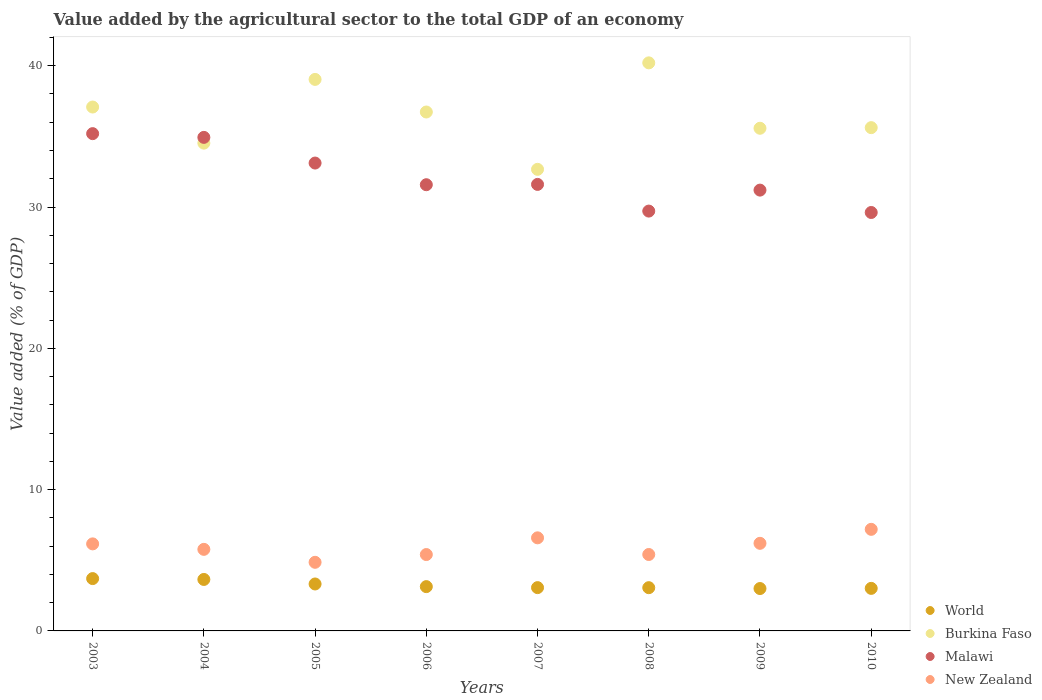How many different coloured dotlines are there?
Offer a terse response. 4. Is the number of dotlines equal to the number of legend labels?
Provide a short and direct response. Yes. What is the value added by the agricultural sector to the total GDP in Burkina Faso in 2009?
Your answer should be very brief. 35.57. Across all years, what is the maximum value added by the agricultural sector to the total GDP in Malawi?
Your response must be concise. 35.19. Across all years, what is the minimum value added by the agricultural sector to the total GDP in New Zealand?
Offer a terse response. 4.86. In which year was the value added by the agricultural sector to the total GDP in New Zealand maximum?
Your answer should be compact. 2010. In which year was the value added by the agricultural sector to the total GDP in Burkina Faso minimum?
Provide a succinct answer. 2007. What is the total value added by the agricultural sector to the total GDP in Burkina Faso in the graph?
Make the answer very short. 291.41. What is the difference between the value added by the agricultural sector to the total GDP in Burkina Faso in 2004 and that in 2007?
Provide a short and direct response. 1.85. What is the difference between the value added by the agricultural sector to the total GDP in Malawi in 2006 and the value added by the agricultural sector to the total GDP in Burkina Faso in 2009?
Give a very brief answer. -4. What is the average value added by the agricultural sector to the total GDP in Burkina Faso per year?
Give a very brief answer. 36.43. In the year 2005, what is the difference between the value added by the agricultural sector to the total GDP in New Zealand and value added by the agricultural sector to the total GDP in Burkina Faso?
Make the answer very short. -34.17. What is the ratio of the value added by the agricultural sector to the total GDP in Burkina Faso in 2005 to that in 2009?
Ensure brevity in your answer.  1.1. Is the value added by the agricultural sector to the total GDP in Malawi in 2009 less than that in 2010?
Offer a very short reply. No. Is the difference between the value added by the agricultural sector to the total GDP in New Zealand in 2009 and 2010 greater than the difference between the value added by the agricultural sector to the total GDP in Burkina Faso in 2009 and 2010?
Provide a short and direct response. No. What is the difference between the highest and the second highest value added by the agricultural sector to the total GDP in World?
Give a very brief answer. 0.06. What is the difference between the highest and the lowest value added by the agricultural sector to the total GDP in Malawi?
Ensure brevity in your answer.  5.58. In how many years, is the value added by the agricultural sector to the total GDP in Malawi greater than the average value added by the agricultural sector to the total GDP in Malawi taken over all years?
Your response must be concise. 3. Is the sum of the value added by the agricultural sector to the total GDP in New Zealand in 2003 and 2008 greater than the maximum value added by the agricultural sector to the total GDP in Malawi across all years?
Offer a terse response. No. Is it the case that in every year, the sum of the value added by the agricultural sector to the total GDP in Burkina Faso and value added by the agricultural sector to the total GDP in World  is greater than the sum of value added by the agricultural sector to the total GDP in Malawi and value added by the agricultural sector to the total GDP in New Zealand?
Ensure brevity in your answer.  No. Is the value added by the agricultural sector to the total GDP in New Zealand strictly greater than the value added by the agricultural sector to the total GDP in Malawi over the years?
Your response must be concise. No. How many dotlines are there?
Your answer should be very brief. 4. How many years are there in the graph?
Your answer should be very brief. 8. Does the graph contain grids?
Give a very brief answer. No. What is the title of the graph?
Make the answer very short. Value added by the agricultural sector to the total GDP of an economy. Does "Greenland" appear as one of the legend labels in the graph?
Offer a terse response. No. What is the label or title of the X-axis?
Your response must be concise. Years. What is the label or title of the Y-axis?
Your answer should be compact. Value added (% of GDP). What is the Value added (% of GDP) in World in 2003?
Ensure brevity in your answer.  3.7. What is the Value added (% of GDP) of Burkina Faso in 2003?
Provide a succinct answer. 37.08. What is the Value added (% of GDP) in Malawi in 2003?
Offer a very short reply. 35.19. What is the Value added (% of GDP) of New Zealand in 2003?
Give a very brief answer. 6.16. What is the Value added (% of GDP) in World in 2004?
Your response must be concise. 3.64. What is the Value added (% of GDP) in Burkina Faso in 2004?
Keep it short and to the point. 34.52. What is the Value added (% of GDP) in Malawi in 2004?
Provide a short and direct response. 34.93. What is the Value added (% of GDP) of New Zealand in 2004?
Give a very brief answer. 5.77. What is the Value added (% of GDP) in World in 2005?
Make the answer very short. 3.32. What is the Value added (% of GDP) in Burkina Faso in 2005?
Make the answer very short. 39.03. What is the Value added (% of GDP) in Malawi in 2005?
Provide a succinct answer. 33.11. What is the Value added (% of GDP) of New Zealand in 2005?
Your response must be concise. 4.86. What is the Value added (% of GDP) of World in 2006?
Your answer should be very brief. 3.13. What is the Value added (% of GDP) of Burkina Faso in 2006?
Your response must be concise. 36.72. What is the Value added (% of GDP) of Malawi in 2006?
Give a very brief answer. 31.58. What is the Value added (% of GDP) in New Zealand in 2006?
Keep it short and to the point. 5.4. What is the Value added (% of GDP) of World in 2007?
Offer a terse response. 3.06. What is the Value added (% of GDP) of Burkina Faso in 2007?
Provide a short and direct response. 32.67. What is the Value added (% of GDP) of Malawi in 2007?
Your answer should be very brief. 31.6. What is the Value added (% of GDP) of New Zealand in 2007?
Your answer should be very brief. 6.59. What is the Value added (% of GDP) in World in 2008?
Your answer should be very brief. 3.06. What is the Value added (% of GDP) in Burkina Faso in 2008?
Offer a very short reply. 40.2. What is the Value added (% of GDP) in Malawi in 2008?
Provide a succinct answer. 29.71. What is the Value added (% of GDP) of New Zealand in 2008?
Your answer should be very brief. 5.41. What is the Value added (% of GDP) in World in 2009?
Provide a succinct answer. 3. What is the Value added (% of GDP) of Burkina Faso in 2009?
Make the answer very short. 35.57. What is the Value added (% of GDP) of Malawi in 2009?
Keep it short and to the point. 31.2. What is the Value added (% of GDP) of New Zealand in 2009?
Your answer should be compact. 6.2. What is the Value added (% of GDP) in World in 2010?
Make the answer very short. 3.01. What is the Value added (% of GDP) of Burkina Faso in 2010?
Your answer should be compact. 35.62. What is the Value added (% of GDP) of Malawi in 2010?
Ensure brevity in your answer.  29.61. What is the Value added (% of GDP) in New Zealand in 2010?
Keep it short and to the point. 7.19. Across all years, what is the maximum Value added (% of GDP) in World?
Make the answer very short. 3.7. Across all years, what is the maximum Value added (% of GDP) in Burkina Faso?
Provide a short and direct response. 40.2. Across all years, what is the maximum Value added (% of GDP) in Malawi?
Offer a very short reply. 35.19. Across all years, what is the maximum Value added (% of GDP) of New Zealand?
Give a very brief answer. 7.19. Across all years, what is the minimum Value added (% of GDP) in World?
Provide a succinct answer. 3. Across all years, what is the minimum Value added (% of GDP) in Burkina Faso?
Give a very brief answer. 32.67. Across all years, what is the minimum Value added (% of GDP) of Malawi?
Provide a succinct answer. 29.61. Across all years, what is the minimum Value added (% of GDP) of New Zealand?
Provide a short and direct response. 4.86. What is the total Value added (% of GDP) of World in the graph?
Your answer should be compact. 25.94. What is the total Value added (% of GDP) of Burkina Faso in the graph?
Your response must be concise. 291.41. What is the total Value added (% of GDP) of Malawi in the graph?
Provide a short and direct response. 256.93. What is the total Value added (% of GDP) of New Zealand in the graph?
Make the answer very short. 47.58. What is the difference between the Value added (% of GDP) in World in 2003 and that in 2004?
Offer a terse response. 0.06. What is the difference between the Value added (% of GDP) in Burkina Faso in 2003 and that in 2004?
Offer a terse response. 2.56. What is the difference between the Value added (% of GDP) of Malawi in 2003 and that in 2004?
Your answer should be very brief. 0.26. What is the difference between the Value added (% of GDP) of New Zealand in 2003 and that in 2004?
Provide a short and direct response. 0.39. What is the difference between the Value added (% of GDP) of World in 2003 and that in 2005?
Your answer should be compact. 0.38. What is the difference between the Value added (% of GDP) in Burkina Faso in 2003 and that in 2005?
Provide a short and direct response. -1.96. What is the difference between the Value added (% of GDP) in Malawi in 2003 and that in 2005?
Make the answer very short. 2.08. What is the difference between the Value added (% of GDP) in New Zealand in 2003 and that in 2005?
Make the answer very short. 1.3. What is the difference between the Value added (% of GDP) in World in 2003 and that in 2006?
Your answer should be compact. 0.57. What is the difference between the Value added (% of GDP) of Burkina Faso in 2003 and that in 2006?
Give a very brief answer. 0.35. What is the difference between the Value added (% of GDP) of Malawi in 2003 and that in 2006?
Your answer should be very brief. 3.61. What is the difference between the Value added (% of GDP) in New Zealand in 2003 and that in 2006?
Your response must be concise. 0.76. What is the difference between the Value added (% of GDP) in World in 2003 and that in 2007?
Your answer should be compact. 0.64. What is the difference between the Value added (% of GDP) in Burkina Faso in 2003 and that in 2007?
Make the answer very short. 4.41. What is the difference between the Value added (% of GDP) of Malawi in 2003 and that in 2007?
Ensure brevity in your answer.  3.59. What is the difference between the Value added (% of GDP) in New Zealand in 2003 and that in 2007?
Offer a very short reply. -0.43. What is the difference between the Value added (% of GDP) in World in 2003 and that in 2008?
Make the answer very short. 0.64. What is the difference between the Value added (% of GDP) in Burkina Faso in 2003 and that in 2008?
Ensure brevity in your answer.  -3.13. What is the difference between the Value added (% of GDP) in Malawi in 2003 and that in 2008?
Your answer should be very brief. 5.48. What is the difference between the Value added (% of GDP) in New Zealand in 2003 and that in 2008?
Make the answer very short. 0.75. What is the difference between the Value added (% of GDP) of World in 2003 and that in 2009?
Your response must be concise. 0.7. What is the difference between the Value added (% of GDP) in Burkina Faso in 2003 and that in 2009?
Provide a short and direct response. 1.5. What is the difference between the Value added (% of GDP) in Malawi in 2003 and that in 2009?
Provide a succinct answer. 4. What is the difference between the Value added (% of GDP) in New Zealand in 2003 and that in 2009?
Keep it short and to the point. -0.04. What is the difference between the Value added (% of GDP) of World in 2003 and that in 2010?
Your response must be concise. 0.69. What is the difference between the Value added (% of GDP) of Burkina Faso in 2003 and that in 2010?
Your response must be concise. 1.46. What is the difference between the Value added (% of GDP) of Malawi in 2003 and that in 2010?
Keep it short and to the point. 5.58. What is the difference between the Value added (% of GDP) of New Zealand in 2003 and that in 2010?
Your response must be concise. -1.03. What is the difference between the Value added (% of GDP) in World in 2004 and that in 2005?
Offer a very short reply. 0.32. What is the difference between the Value added (% of GDP) in Burkina Faso in 2004 and that in 2005?
Your answer should be compact. -4.51. What is the difference between the Value added (% of GDP) of Malawi in 2004 and that in 2005?
Your answer should be compact. 1.82. What is the difference between the Value added (% of GDP) of New Zealand in 2004 and that in 2005?
Make the answer very short. 0.92. What is the difference between the Value added (% of GDP) of World in 2004 and that in 2006?
Your response must be concise. 0.51. What is the difference between the Value added (% of GDP) of Burkina Faso in 2004 and that in 2006?
Provide a succinct answer. -2.2. What is the difference between the Value added (% of GDP) of Malawi in 2004 and that in 2006?
Make the answer very short. 3.35. What is the difference between the Value added (% of GDP) in New Zealand in 2004 and that in 2006?
Offer a very short reply. 0.37. What is the difference between the Value added (% of GDP) of World in 2004 and that in 2007?
Make the answer very short. 0.58. What is the difference between the Value added (% of GDP) in Burkina Faso in 2004 and that in 2007?
Ensure brevity in your answer.  1.85. What is the difference between the Value added (% of GDP) of Malawi in 2004 and that in 2007?
Keep it short and to the point. 3.33. What is the difference between the Value added (% of GDP) in New Zealand in 2004 and that in 2007?
Keep it short and to the point. -0.81. What is the difference between the Value added (% of GDP) of World in 2004 and that in 2008?
Your answer should be compact. 0.58. What is the difference between the Value added (% of GDP) of Burkina Faso in 2004 and that in 2008?
Offer a terse response. -5.68. What is the difference between the Value added (% of GDP) of Malawi in 2004 and that in 2008?
Offer a very short reply. 5.22. What is the difference between the Value added (% of GDP) of New Zealand in 2004 and that in 2008?
Provide a succinct answer. 0.36. What is the difference between the Value added (% of GDP) in World in 2004 and that in 2009?
Provide a succinct answer. 0.64. What is the difference between the Value added (% of GDP) of Burkina Faso in 2004 and that in 2009?
Provide a short and direct response. -1.05. What is the difference between the Value added (% of GDP) in Malawi in 2004 and that in 2009?
Your response must be concise. 3.73. What is the difference between the Value added (% of GDP) in New Zealand in 2004 and that in 2009?
Your answer should be compact. -0.43. What is the difference between the Value added (% of GDP) of World in 2004 and that in 2010?
Your answer should be very brief. 0.63. What is the difference between the Value added (% of GDP) in Burkina Faso in 2004 and that in 2010?
Offer a very short reply. -1.1. What is the difference between the Value added (% of GDP) in Malawi in 2004 and that in 2010?
Offer a terse response. 5.32. What is the difference between the Value added (% of GDP) of New Zealand in 2004 and that in 2010?
Offer a terse response. -1.42. What is the difference between the Value added (% of GDP) in World in 2005 and that in 2006?
Your answer should be very brief. 0.19. What is the difference between the Value added (% of GDP) of Burkina Faso in 2005 and that in 2006?
Provide a short and direct response. 2.31. What is the difference between the Value added (% of GDP) of Malawi in 2005 and that in 2006?
Give a very brief answer. 1.53. What is the difference between the Value added (% of GDP) of New Zealand in 2005 and that in 2006?
Give a very brief answer. -0.55. What is the difference between the Value added (% of GDP) of World in 2005 and that in 2007?
Provide a succinct answer. 0.26. What is the difference between the Value added (% of GDP) in Burkina Faso in 2005 and that in 2007?
Provide a succinct answer. 6.36. What is the difference between the Value added (% of GDP) of Malawi in 2005 and that in 2007?
Offer a terse response. 1.51. What is the difference between the Value added (% of GDP) of New Zealand in 2005 and that in 2007?
Give a very brief answer. -1.73. What is the difference between the Value added (% of GDP) in World in 2005 and that in 2008?
Make the answer very short. 0.26. What is the difference between the Value added (% of GDP) of Burkina Faso in 2005 and that in 2008?
Your answer should be compact. -1.17. What is the difference between the Value added (% of GDP) of Malawi in 2005 and that in 2008?
Keep it short and to the point. 3.4. What is the difference between the Value added (% of GDP) of New Zealand in 2005 and that in 2008?
Offer a terse response. -0.55. What is the difference between the Value added (% of GDP) in World in 2005 and that in 2009?
Your answer should be very brief. 0.32. What is the difference between the Value added (% of GDP) in Burkina Faso in 2005 and that in 2009?
Provide a short and direct response. 3.46. What is the difference between the Value added (% of GDP) in Malawi in 2005 and that in 2009?
Offer a terse response. 1.92. What is the difference between the Value added (% of GDP) in New Zealand in 2005 and that in 2009?
Offer a very short reply. -1.34. What is the difference between the Value added (% of GDP) of World in 2005 and that in 2010?
Provide a short and direct response. 0.31. What is the difference between the Value added (% of GDP) of Burkina Faso in 2005 and that in 2010?
Your answer should be compact. 3.41. What is the difference between the Value added (% of GDP) of Malawi in 2005 and that in 2010?
Your answer should be compact. 3.5. What is the difference between the Value added (% of GDP) of New Zealand in 2005 and that in 2010?
Your response must be concise. -2.33. What is the difference between the Value added (% of GDP) of World in 2006 and that in 2007?
Keep it short and to the point. 0.07. What is the difference between the Value added (% of GDP) of Burkina Faso in 2006 and that in 2007?
Your answer should be very brief. 4.06. What is the difference between the Value added (% of GDP) of Malawi in 2006 and that in 2007?
Your answer should be compact. -0.02. What is the difference between the Value added (% of GDP) in New Zealand in 2006 and that in 2007?
Keep it short and to the point. -1.18. What is the difference between the Value added (% of GDP) of World in 2006 and that in 2008?
Offer a terse response. 0.07. What is the difference between the Value added (% of GDP) in Burkina Faso in 2006 and that in 2008?
Your answer should be compact. -3.48. What is the difference between the Value added (% of GDP) of Malawi in 2006 and that in 2008?
Your answer should be very brief. 1.87. What is the difference between the Value added (% of GDP) in New Zealand in 2006 and that in 2008?
Your answer should be very brief. -0. What is the difference between the Value added (% of GDP) of World in 2006 and that in 2009?
Keep it short and to the point. 0.14. What is the difference between the Value added (% of GDP) in Burkina Faso in 2006 and that in 2009?
Provide a short and direct response. 1.15. What is the difference between the Value added (% of GDP) of Malawi in 2006 and that in 2009?
Ensure brevity in your answer.  0.38. What is the difference between the Value added (% of GDP) in New Zealand in 2006 and that in 2009?
Offer a very short reply. -0.79. What is the difference between the Value added (% of GDP) in World in 2006 and that in 2010?
Offer a very short reply. 0.12. What is the difference between the Value added (% of GDP) in Burkina Faso in 2006 and that in 2010?
Your answer should be very brief. 1.11. What is the difference between the Value added (% of GDP) of Malawi in 2006 and that in 2010?
Your answer should be compact. 1.97. What is the difference between the Value added (% of GDP) in New Zealand in 2006 and that in 2010?
Make the answer very short. -1.78. What is the difference between the Value added (% of GDP) in World in 2007 and that in 2008?
Ensure brevity in your answer.  0. What is the difference between the Value added (% of GDP) in Burkina Faso in 2007 and that in 2008?
Provide a succinct answer. -7.54. What is the difference between the Value added (% of GDP) in Malawi in 2007 and that in 2008?
Give a very brief answer. 1.89. What is the difference between the Value added (% of GDP) of New Zealand in 2007 and that in 2008?
Offer a very short reply. 1.18. What is the difference between the Value added (% of GDP) of World in 2007 and that in 2009?
Give a very brief answer. 0.06. What is the difference between the Value added (% of GDP) in Burkina Faso in 2007 and that in 2009?
Ensure brevity in your answer.  -2.91. What is the difference between the Value added (% of GDP) of Malawi in 2007 and that in 2009?
Provide a succinct answer. 0.4. What is the difference between the Value added (% of GDP) of New Zealand in 2007 and that in 2009?
Ensure brevity in your answer.  0.39. What is the difference between the Value added (% of GDP) in World in 2007 and that in 2010?
Offer a terse response. 0.05. What is the difference between the Value added (% of GDP) of Burkina Faso in 2007 and that in 2010?
Offer a terse response. -2.95. What is the difference between the Value added (% of GDP) in Malawi in 2007 and that in 2010?
Ensure brevity in your answer.  1.99. What is the difference between the Value added (% of GDP) in New Zealand in 2007 and that in 2010?
Give a very brief answer. -0.6. What is the difference between the Value added (% of GDP) of World in 2008 and that in 2009?
Your answer should be compact. 0.06. What is the difference between the Value added (% of GDP) in Burkina Faso in 2008 and that in 2009?
Your answer should be very brief. 4.63. What is the difference between the Value added (% of GDP) in Malawi in 2008 and that in 2009?
Your response must be concise. -1.48. What is the difference between the Value added (% of GDP) of New Zealand in 2008 and that in 2009?
Make the answer very short. -0.79. What is the difference between the Value added (% of GDP) of World in 2008 and that in 2010?
Make the answer very short. 0.05. What is the difference between the Value added (% of GDP) of Burkina Faso in 2008 and that in 2010?
Make the answer very short. 4.58. What is the difference between the Value added (% of GDP) of Malawi in 2008 and that in 2010?
Keep it short and to the point. 0.1. What is the difference between the Value added (% of GDP) in New Zealand in 2008 and that in 2010?
Make the answer very short. -1.78. What is the difference between the Value added (% of GDP) of World in 2009 and that in 2010?
Keep it short and to the point. -0.01. What is the difference between the Value added (% of GDP) of Burkina Faso in 2009 and that in 2010?
Your answer should be very brief. -0.04. What is the difference between the Value added (% of GDP) in Malawi in 2009 and that in 2010?
Provide a succinct answer. 1.58. What is the difference between the Value added (% of GDP) of New Zealand in 2009 and that in 2010?
Provide a succinct answer. -0.99. What is the difference between the Value added (% of GDP) of World in 2003 and the Value added (% of GDP) of Burkina Faso in 2004?
Offer a very short reply. -30.82. What is the difference between the Value added (% of GDP) in World in 2003 and the Value added (% of GDP) in Malawi in 2004?
Your answer should be very brief. -31.23. What is the difference between the Value added (% of GDP) of World in 2003 and the Value added (% of GDP) of New Zealand in 2004?
Offer a terse response. -2.07. What is the difference between the Value added (% of GDP) in Burkina Faso in 2003 and the Value added (% of GDP) in Malawi in 2004?
Your response must be concise. 2.15. What is the difference between the Value added (% of GDP) in Burkina Faso in 2003 and the Value added (% of GDP) in New Zealand in 2004?
Give a very brief answer. 31.3. What is the difference between the Value added (% of GDP) of Malawi in 2003 and the Value added (% of GDP) of New Zealand in 2004?
Provide a short and direct response. 29.42. What is the difference between the Value added (% of GDP) of World in 2003 and the Value added (% of GDP) of Burkina Faso in 2005?
Keep it short and to the point. -35.33. What is the difference between the Value added (% of GDP) in World in 2003 and the Value added (% of GDP) in Malawi in 2005?
Keep it short and to the point. -29.41. What is the difference between the Value added (% of GDP) in World in 2003 and the Value added (% of GDP) in New Zealand in 2005?
Provide a succinct answer. -1.15. What is the difference between the Value added (% of GDP) of Burkina Faso in 2003 and the Value added (% of GDP) of Malawi in 2005?
Your answer should be very brief. 3.96. What is the difference between the Value added (% of GDP) of Burkina Faso in 2003 and the Value added (% of GDP) of New Zealand in 2005?
Provide a short and direct response. 32.22. What is the difference between the Value added (% of GDP) of Malawi in 2003 and the Value added (% of GDP) of New Zealand in 2005?
Your response must be concise. 30.34. What is the difference between the Value added (% of GDP) of World in 2003 and the Value added (% of GDP) of Burkina Faso in 2006?
Make the answer very short. -33.02. What is the difference between the Value added (% of GDP) of World in 2003 and the Value added (% of GDP) of Malawi in 2006?
Your answer should be very brief. -27.87. What is the difference between the Value added (% of GDP) of World in 2003 and the Value added (% of GDP) of New Zealand in 2006?
Provide a short and direct response. -1.7. What is the difference between the Value added (% of GDP) of Burkina Faso in 2003 and the Value added (% of GDP) of Malawi in 2006?
Offer a terse response. 5.5. What is the difference between the Value added (% of GDP) of Burkina Faso in 2003 and the Value added (% of GDP) of New Zealand in 2006?
Ensure brevity in your answer.  31.67. What is the difference between the Value added (% of GDP) in Malawi in 2003 and the Value added (% of GDP) in New Zealand in 2006?
Offer a very short reply. 29.79. What is the difference between the Value added (% of GDP) in World in 2003 and the Value added (% of GDP) in Burkina Faso in 2007?
Offer a terse response. -28.96. What is the difference between the Value added (% of GDP) of World in 2003 and the Value added (% of GDP) of Malawi in 2007?
Provide a short and direct response. -27.9. What is the difference between the Value added (% of GDP) in World in 2003 and the Value added (% of GDP) in New Zealand in 2007?
Ensure brevity in your answer.  -2.88. What is the difference between the Value added (% of GDP) of Burkina Faso in 2003 and the Value added (% of GDP) of Malawi in 2007?
Provide a short and direct response. 5.48. What is the difference between the Value added (% of GDP) of Burkina Faso in 2003 and the Value added (% of GDP) of New Zealand in 2007?
Make the answer very short. 30.49. What is the difference between the Value added (% of GDP) of Malawi in 2003 and the Value added (% of GDP) of New Zealand in 2007?
Offer a very short reply. 28.6. What is the difference between the Value added (% of GDP) in World in 2003 and the Value added (% of GDP) in Burkina Faso in 2008?
Your answer should be compact. -36.5. What is the difference between the Value added (% of GDP) of World in 2003 and the Value added (% of GDP) of Malawi in 2008?
Your answer should be very brief. -26.01. What is the difference between the Value added (% of GDP) in World in 2003 and the Value added (% of GDP) in New Zealand in 2008?
Ensure brevity in your answer.  -1.71. What is the difference between the Value added (% of GDP) of Burkina Faso in 2003 and the Value added (% of GDP) of Malawi in 2008?
Give a very brief answer. 7.36. What is the difference between the Value added (% of GDP) of Burkina Faso in 2003 and the Value added (% of GDP) of New Zealand in 2008?
Offer a very short reply. 31.67. What is the difference between the Value added (% of GDP) in Malawi in 2003 and the Value added (% of GDP) in New Zealand in 2008?
Provide a short and direct response. 29.78. What is the difference between the Value added (% of GDP) in World in 2003 and the Value added (% of GDP) in Burkina Faso in 2009?
Provide a succinct answer. -31.87. What is the difference between the Value added (% of GDP) in World in 2003 and the Value added (% of GDP) in Malawi in 2009?
Provide a short and direct response. -27.49. What is the difference between the Value added (% of GDP) in World in 2003 and the Value added (% of GDP) in New Zealand in 2009?
Provide a succinct answer. -2.5. What is the difference between the Value added (% of GDP) in Burkina Faso in 2003 and the Value added (% of GDP) in Malawi in 2009?
Your answer should be compact. 5.88. What is the difference between the Value added (% of GDP) of Burkina Faso in 2003 and the Value added (% of GDP) of New Zealand in 2009?
Provide a succinct answer. 30.88. What is the difference between the Value added (% of GDP) of Malawi in 2003 and the Value added (% of GDP) of New Zealand in 2009?
Provide a short and direct response. 28.99. What is the difference between the Value added (% of GDP) in World in 2003 and the Value added (% of GDP) in Burkina Faso in 2010?
Offer a terse response. -31.91. What is the difference between the Value added (% of GDP) in World in 2003 and the Value added (% of GDP) in Malawi in 2010?
Offer a terse response. -25.91. What is the difference between the Value added (% of GDP) of World in 2003 and the Value added (% of GDP) of New Zealand in 2010?
Your answer should be very brief. -3.49. What is the difference between the Value added (% of GDP) of Burkina Faso in 2003 and the Value added (% of GDP) of Malawi in 2010?
Offer a terse response. 7.46. What is the difference between the Value added (% of GDP) of Burkina Faso in 2003 and the Value added (% of GDP) of New Zealand in 2010?
Offer a terse response. 29.89. What is the difference between the Value added (% of GDP) in Malawi in 2003 and the Value added (% of GDP) in New Zealand in 2010?
Your response must be concise. 28. What is the difference between the Value added (% of GDP) in World in 2004 and the Value added (% of GDP) in Burkina Faso in 2005?
Provide a short and direct response. -35.39. What is the difference between the Value added (% of GDP) in World in 2004 and the Value added (% of GDP) in Malawi in 2005?
Provide a short and direct response. -29.47. What is the difference between the Value added (% of GDP) in World in 2004 and the Value added (% of GDP) in New Zealand in 2005?
Provide a succinct answer. -1.21. What is the difference between the Value added (% of GDP) in Burkina Faso in 2004 and the Value added (% of GDP) in Malawi in 2005?
Make the answer very short. 1.41. What is the difference between the Value added (% of GDP) in Burkina Faso in 2004 and the Value added (% of GDP) in New Zealand in 2005?
Ensure brevity in your answer.  29.66. What is the difference between the Value added (% of GDP) of Malawi in 2004 and the Value added (% of GDP) of New Zealand in 2005?
Your answer should be compact. 30.07. What is the difference between the Value added (% of GDP) in World in 2004 and the Value added (% of GDP) in Burkina Faso in 2006?
Your answer should be very brief. -33.08. What is the difference between the Value added (% of GDP) of World in 2004 and the Value added (% of GDP) of Malawi in 2006?
Your response must be concise. -27.94. What is the difference between the Value added (% of GDP) of World in 2004 and the Value added (% of GDP) of New Zealand in 2006?
Ensure brevity in your answer.  -1.76. What is the difference between the Value added (% of GDP) in Burkina Faso in 2004 and the Value added (% of GDP) in Malawi in 2006?
Give a very brief answer. 2.94. What is the difference between the Value added (% of GDP) of Burkina Faso in 2004 and the Value added (% of GDP) of New Zealand in 2006?
Keep it short and to the point. 29.12. What is the difference between the Value added (% of GDP) of Malawi in 2004 and the Value added (% of GDP) of New Zealand in 2006?
Offer a terse response. 29.52. What is the difference between the Value added (% of GDP) in World in 2004 and the Value added (% of GDP) in Burkina Faso in 2007?
Your answer should be very brief. -29.02. What is the difference between the Value added (% of GDP) of World in 2004 and the Value added (% of GDP) of Malawi in 2007?
Ensure brevity in your answer.  -27.96. What is the difference between the Value added (% of GDP) of World in 2004 and the Value added (% of GDP) of New Zealand in 2007?
Provide a succinct answer. -2.94. What is the difference between the Value added (% of GDP) in Burkina Faso in 2004 and the Value added (% of GDP) in Malawi in 2007?
Give a very brief answer. 2.92. What is the difference between the Value added (% of GDP) in Burkina Faso in 2004 and the Value added (% of GDP) in New Zealand in 2007?
Keep it short and to the point. 27.93. What is the difference between the Value added (% of GDP) of Malawi in 2004 and the Value added (% of GDP) of New Zealand in 2007?
Give a very brief answer. 28.34. What is the difference between the Value added (% of GDP) in World in 2004 and the Value added (% of GDP) in Burkina Faso in 2008?
Give a very brief answer. -36.56. What is the difference between the Value added (% of GDP) in World in 2004 and the Value added (% of GDP) in Malawi in 2008?
Ensure brevity in your answer.  -26.07. What is the difference between the Value added (% of GDP) of World in 2004 and the Value added (% of GDP) of New Zealand in 2008?
Provide a short and direct response. -1.77. What is the difference between the Value added (% of GDP) in Burkina Faso in 2004 and the Value added (% of GDP) in Malawi in 2008?
Give a very brief answer. 4.81. What is the difference between the Value added (% of GDP) of Burkina Faso in 2004 and the Value added (% of GDP) of New Zealand in 2008?
Ensure brevity in your answer.  29.11. What is the difference between the Value added (% of GDP) in Malawi in 2004 and the Value added (% of GDP) in New Zealand in 2008?
Provide a short and direct response. 29.52. What is the difference between the Value added (% of GDP) in World in 2004 and the Value added (% of GDP) in Burkina Faso in 2009?
Your answer should be compact. -31.93. What is the difference between the Value added (% of GDP) of World in 2004 and the Value added (% of GDP) of Malawi in 2009?
Make the answer very short. -27.55. What is the difference between the Value added (% of GDP) of World in 2004 and the Value added (% of GDP) of New Zealand in 2009?
Your response must be concise. -2.56. What is the difference between the Value added (% of GDP) in Burkina Faso in 2004 and the Value added (% of GDP) in Malawi in 2009?
Your response must be concise. 3.32. What is the difference between the Value added (% of GDP) of Burkina Faso in 2004 and the Value added (% of GDP) of New Zealand in 2009?
Your answer should be very brief. 28.32. What is the difference between the Value added (% of GDP) of Malawi in 2004 and the Value added (% of GDP) of New Zealand in 2009?
Offer a very short reply. 28.73. What is the difference between the Value added (% of GDP) in World in 2004 and the Value added (% of GDP) in Burkina Faso in 2010?
Give a very brief answer. -31.97. What is the difference between the Value added (% of GDP) of World in 2004 and the Value added (% of GDP) of Malawi in 2010?
Offer a very short reply. -25.97. What is the difference between the Value added (% of GDP) in World in 2004 and the Value added (% of GDP) in New Zealand in 2010?
Your answer should be compact. -3.55. What is the difference between the Value added (% of GDP) in Burkina Faso in 2004 and the Value added (% of GDP) in Malawi in 2010?
Offer a very short reply. 4.91. What is the difference between the Value added (% of GDP) in Burkina Faso in 2004 and the Value added (% of GDP) in New Zealand in 2010?
Give a very brief answer. 27.33. What is the difference between the Value added (% of GDP) in Malawi in 2004 and the Value added (% of GDP) in New Zealand in 2010?
Offer a very short reply. 27.74. What is the difference between the Value added (% of GDP) of World in 2005 and the Value added (% of GDP) of Burkina Faso in 2006?
Your answer should be very brief. -33.4. What is the difference between the Value added (% of GDP) in World in 2005 and the Value added (% of GDP) in Malawi in 2006?
Offer a terse response. -28.26. What is the difference between the Value added (% of GDP) of World in 2005 and the Value added (% of GDP) of New Zealand in 2006?
Offer a terse response. -2.08. What is the difference between the Value added (% of GDP) in Burkina Faso in 2005 and the Value added (% of GDP) in Malawi in 2006?
Ensure brevity in your answer.  7.45. What is the difference between the Value added (% of GDP) of Burkina Faso in 2005 and the Value added (% of GDP) of New Zealand in 2006?
Your answer should be very brief. 33.63. What is the difference between the Value added (% of GDP) of Malawi in 2005 and the Value added (% of GDP) of New Zealand in 2006?
Offer a very short reply. 27.71. What is the difference between the Value added (% of GDP) of World in 2005 and the Value added (% of GDP) of Burkina Faso in 2007?
Offer a terse response. -29.34. What is the difference between the Value added (% of GDP) in World in 2005 and the Value added (% of GDP) in Malawi in 2007?
Offer a very short reply. -28.28. What is the difference between the Value added (% of GDP) in World in 2005 and the Value added (% of GDP) in New Zealand in 2007?
Ensure brevity in your answer.  -3.27. What is the difference between the Value added (% of GDP) of Burkina Faso in 2005 and the Value added (% of GDP) of Malawi in 2007?
Ensure brevity in your answer.  7.43. What is the difference between the Value added (% of GDP) in Burkina Faso in 2005 and the Value added (% of GDP) in New Zealand in 2007?
Offer a very short reply. 32.44. What is the difference between the Value added (% of GDP) of Malawi in 2005 and the Value added (% of GDP) of New Zealand in 2007?
Your answer should be very brief. 26.52. What is the difference between the Value added (% of GDP) of World in 2005 and the Value added (% of GDP) of Burkina Faso in 2008?
Provide a succinct answer. -36.88. What is the difference between the Value added (% of GDP) in World in 2005 and the Value added (% of GDP) in Malawi in 2008?
Provide a succinct answer. -26.39. What is the difference between the Value added (% of GDP) of World in 2005 and the Value added (% of GDP) of New Zealand in 2008?
Offer a very short reply. -2.09. What is the difference between the Value added (% of GDP) of Burkina Faso in 2005 and the Value added (% of GDP) of Malawi in 2008?
Provide a short and direct response. 9.32. What is the difference between the Value added (% of GDP) in Burkina Faso in 2005 and the Value added (% of GDP) in New Zealand in 2008?
Provide a succinct answer. 33.62. What is the difference between the Value added (% of GDP) in Malawi in 2005 and the Value added (% of GDP) in New Zealand in 2008?
Give a very brief answer. 27.7. What is the difference between the Value added (% of GDP) in World in 2005 and the Value added (% of GDP) in Burkina Faso in 2009?
Keep it short and to the point. -32.25. What is the difference between the Value added (% of GDP) in World in 2005 and the Value added (% of GDP) in Malawi in 2009?
Your response must be concise. -27.87. What is the difference between the Value added (% of GDP) in World in 2005 and the Value added (% of GDP) in New Zealand in 2009?
Make the answer very short. -2.88. What is the difference between the Value added (% of GDP) in Burkina Faso in 2005 and the Value added (% of GDP) in Malawi in 2009?
Offer a very short reply. 7.83. What is the difference between the Value added (% of GDP) of Burkina Faso in 2005 and the Value added (% of GDP) of New Zealand in 2009?
Provide a short and direct response. 32.83. What is the difference between the Value added (% of GDP) of Malawi in 2005 and the Value added (% of GDP) of New Zealand in 2009?
Your answer should be very brief. 26.91. What is the difference between the Value added (% of GDP) in World in 2005 and the Value added (% of GDP) in Burkina Faso in 2010?
Your answer should be compact. -32.29. What is the difference between the Value added (% of GDP) of World in 2005 and the Value added (% of GDP) of Malawi in 2010?
Keep it short and to the point. -26.29. What is the difference between the Value added (% of GDP) in World in 2005 and the Value added (% of GDP) in New Zealand in 2010?
Ensure brevity in your answer.  -3.87. What is the difference between the Value added (% of GDP) of Burkina Faso in 2005 and the Value added (% of GDP) of Malawi in 2010?
Your response must be concise. 9.42. What is the difference between the Value added (% of GDP) in Burkina Faso in 2005 and the Value added (% of GDP) in New Zealand in 2010?
Give a very brief answer. 31.84. What is the difference between the Value added (% of GDP) of Malawi in 2005 and the Value added (% of GDP) of New Zealand in 2010?
Offer a terse response. 25.92. What is the difference between the Value added (% of GDP) of World in 2006 and the Value added (% of GDP) of Burkina Faso in 2007?
Your answer should be compact. -29.53. What is the difference between the Value added (% of GDP) in World in 2006 and the Value added (% of GDP) in Malawi in 2007?
Your response must be concise. -28.46. What is the difference between the Value added (% of GDP) in World in 2006 and the Value added (% of GDP) in New Zealand in 2007?
Keep it short and to the point. -3.45. What is the difference between the Value added (% of GDP) of Burkina Faso in 2006 and the Value added (% of GDP) of Malawi in 2007?
Offer a very short reply. 5.12. What is the difference between the Value added (% of GDP) in Burkina Faso in 2006 and the Value added (% of GDP) in New Zealand in 2007?
Provide a short and direct response. 30.14. What is the difference between the Value added (% of GDP) in Malawi in 2006 and the Value added (% of GDP) in New Zealand in 2007?
Your answer should be very brief. 24.99. What is the difference between the Value added (% of GDP) of World in 2006 and the Value added (% of GDP) of Burkina Faso in 2008?
Give a very brief answer. -37.07. What is the difference between the Value added (% of GDP) of World in 2006 and the Value added (% of GDP) of Malawi in 2008?
Give a very brief answer. -26.58. What is the difference between the Value added (% of GDP) in World in 2006 and the Value added (% of GDP) in New Zealand in 2008?
Make the answer very short. -2.27. What is the difference between the Value added (% of GDP) of Burkina Faso in 2006 and the Value added (% of GDP) of Malawi in 2008?
Give a very brief answer. 7.01. What is the difference between the Value added (% of GDP) of Burkina Faso in 2006 and the Value added (% of GDP) of New Zealand in 2008?
Your answer should be compact. 31.32. What is the difference between the Value added (% of GDP) in Malawi in 2006 and the Value added (% of GDP) in New Zealand in 2008?
Offer a terse response. 26.17. What is the difference between the Value added (% of GDP) of World in 2006 and the Value added (% of GDP) of Burkina Faso in 2009?
Ensure brevity in your answer.  -32.44. What is the difference between the Value added (% of GDP) of World in 2006 and the Value added (% of GDP) of Malawi in 2009?
Your answer should be very brief. -28.06. What is the difference between the Value added (% of GDP) in World in 2006 and the Value added (% of GDP) in New Zealand in 2009?
Your answer should be compact. -3.06. What is the difference between the Value added (% of GDP) in Burkina Faso in 2006 and the Value added (% of GDP) in Malawi in 2009?
Your response must be concise. 5.53. What is the difference between the Value added (% of GDP) in Burkina Faso in 2006 and the Value added (% of GDP) in New Zealand in 2009?
Make the answer very short. 30.52. What is the difference between the Value added (% of GDP) of Malawi in 2006 and the Value added (% of GDP) of New Zealand in 2009?
Your response must be concise. 25.38. What is the difference between the Value added (% of GDP) in World in 2006 and the Value added (% of GDP) in Burkina Faso in 2010?
Offer a very short reply. -32.48. What is the difference between the Value added (% of GDP) in World in 2006 and the Value added (% of GDP) in Malawi in 2010?
Your response must be concise. -26.48. What is the difference between the Value added (% of GDP) of World in 2006 and the Value added (% of GDP) of New Zealand in 2010?
Ensure brevity in your answer.  -4.05. What is the difference between the Value added (% of GDP) in Burkina Faso in 2006 and the Value added (% of GDP) in Malawi in 2010?
Offer a terse response. 7.11. What is the difference between the Value added (% of GDP) in Burkina Faso in 2006 and the Value added (% of GDP) in New Zealand in 2010?
Your answer should be very brief. 29.53. What is the difference between the Value added (% of GDP) of Malawi in 2006 and the Value added (% of GDP) of New Zealand in 2010?
Your answer should be very brief. 24.39. What is the difference between the Value added (% of GDP) in World in 2007 and the Value added (% of GDP) in Burkina Faso in 2008?
Your answer should be compact. -37.14. What is the difference between the Value added (% of GDP) in World in 2007 and the Value added (% of GDP) in Malawi in 2008?
Provide a short and direct response. -26.65. What is the difference between the Value added (% of GDP) of World in 2007 and the Value added (% of GDP) of New Zealand in 2008?
Your answer should be very brief. -2.34. What is the difference between the Value added (% of GDP) of Burkina Faso in 2007 and the Value added (% of GDP) of Malawi in 2008?
Make the answer very short. 2.95. What is the difference between the Value added (% of GDP) of Burkina Faso in 2007 and the Value added (% of GDP) of New Zealand in 2008?
Offer a terse response. 27.26. What is the difference between the Value added (% of GDP) in Malawi in 2007 and the Value added (% of GDP) in New Zealand in 2008?
Provide a short and direct response. 26.19. What is the difference between the Value added (% of GDP) of World in 2007 and the Value added (% of GDP) of Burkina Faso in 2009?
Keep it short and to the point. -32.51. What is the difference between the Value added (% of GDP) in World in 2007 and the Value added (% of GDP) in Malawi in 2009?
Your answer should be very brief. -28.13. What is the difference between the Value added (% of GDP) of World in 2007 and the Value added (% of GDP) of New Zealand in 2009?
Offer a very short reply. -3.14. What is the difference between the Value added (% of GDP) in Burkina Faso in 2007 and the Value added (% of GDP) in Malawi in 2009?
Offer a very short reply. 1.47. What is the difference between the Value added (% of GDP) in Burkina Faso in 2007 and the Value added (% of GDP) in New Zealand in 2009?
Offer a very short reply. 26.47. What is the difference between the Value added (% of GDP) of Malawi in 2007 and the Value added (% of GDP) of New Zealand in 2009?
Provide a succinct answer. 25.4. What is the difference between the Value added (% of GDP) in World in 2007 and the Value added (% of GDP) in Burkina Faso in 2010?
Provide a short and direct response. -32.55. What is the difference between the Value added (% of GDP) in World in 2007 and the Value added (% of GDP) in Malawi in 2010?
Your answer should be compact. -26.55. What is the difference between the Value added (% of GDP) of World in 2007 and the Value added (% of GDP) of New Zealand in 2010?
Provide a short and direct response. -4.13. What is the difference between the Value added (% of GDP) in Burkina Faso in 2007 and the Value added (% of GDP) in Malawi in 2010?
Ensure brevity in your answer.  3.05. What is the difference between the Value added (% of GDP) in Burkina Faso in 2007 and the Value added (% of GDP) in New Zealand in 2010?
Offer a terse response. 25.48. What is the difference between the Value added (% of GDP) in Malawi in 2007 and the Value added (% of GDP) in New Zealand in 2010?
Provide a short and direct response. 24.41. What is the difference between the Value added (% of GDP) of World in 2008 and the Value added (% of GDP) of Burkina Faso in 2009?
Provide a succinct answer. -32.51. What is the difference between the Value added (% of GDP) in World in 2008 and the Value added (% of GDP) in Malawi in 2009?
Give a very brief answer. -28.14. What is the difference between the Value added (% of GDP) in World in 2008 and the Value added (% of GDP) in New Zealand in 2009?
Keep it short and to the point. -3.14. What is the difference between the Value added (% of GDP) in Burkina Faso in 2008 and the Value added (% of GDP) in Malawi in 2009?
Your answer should be very brief. 9.01. What is the difference between the Value added (% of GDP) in Burkina Faso in 2008 and the Value added (% of GDP) in New Zealand in 2009?
Provide a succinct answer. 34. What is the difference between the Value added (% of GDP) in Malawi in 2008 and the Value added (% of GDP) in New Zealand in 2009?
Ensure brevity in your answer.  23.51. What is the difference between the Value added (% of GDP) of World in 2008 and the Value added (% of GDP) of Burkina Faso in 2010?
Ensure brevity in your answer.  -32.56. What is the difference between the Value added (% of GDP) in World in 2008 and the Value added (% of GDP) in Malawi in 2010?
Your answer should be compact. -26.55. What is the difference between the Value added (% of GDP) of World in 2008 and the Value added (% of GDP) of New Zealand in 2010?
Provide a short and direct response. -4.13. What is the difference between the Value added (% of GDP) of Burkina Faso in 2008 and the Value added (% of GDP) of Malawi in 2010?
Keep it short and to the point. 10.59. What is the difference between the Value added (% of GDP) in Burkina Faso in 2008 and the Value added (% of GDP) in New Zealand in 2010?
Ensure brevity in your answer.  33.01. What is the difference between the Value added (% of GDP) in Malawi in 2008 and the Value added (% of GDP) in New Zealand in 2010?
Your response must be concise. 22.52. What is the difference between the Value added (% of GDP) of World in 2009 and the Value added (% of GDP) of Burkina Faso in 2010?
Provide a succinct answer. -32.62. What is the difference between the Value added (% of GDP) in World in 2009 and the Value added (% of GDP) in Malawi in 2010?
Make the answer very short. -26.61. What is the difference between the Value added (% of GDP) in World in 2009 and the Value added (% of GDP) in New Zealand in 2010?
Make the answer very short. -4.19. What is the difference between the Value added (% of GDP) of Burkina Faso in 2009 and the Value added (% of GDP) of Malawi in 2010?
Offer a very short reply. 5.96. What is the difference between the Value added (% of GDP) of Burkina Faso in 2009 and the Value added (% of GDP) of New Zealand in 2010?
Your answer should be very brief. 28.38. What is the difference between the Value added (% of GDP) of Malawi in 2009 and the Value added (% of GDP) of New Zealand in 2010?
Offer a very short reply. 24.01. What is the average Value added (% of GDP) of World per year?
Give a very brief answer. 3.24. What is the average Value added (% of GDP) in Burkina Faso per year?
Give a very brief answer. 36.43. What is the average Value added (% of GDP) in Malawi per year?
Give a very brief answer. 32.12. What is the average Value added (% of GDP) in New Zealand per year?
Offer a very short reply. 5.95. In the year 2003, what is the difference between the Value added (% of GDP) in World and Value added (% of GDP) in Burkina Faso?
Provide a short and direct response. -33.37. In the year 2003, what is the difference between the Value added (% of GDP) of World and Value added (% of GDP) of Malawi?
Offer a terse response. -31.49. In the year 2003, what is the difference between the Value added (% of GDP) in World and Value added (% of GDP) in New Zealand?
Your answer should be compact. -2.46. In the year 2003, what is the difference between the Value added (% of GDP) in Burkina Faso and Value added (% of GDP) in Malawi?
Ensure brevity in your answer.  1.88. In the year 2003, what is the difference between the Value added (% of GDP) in Burkina Faso and Value added (% of GDP) in New Zealand?
Make the answer very short. 30.92. In the year 2003, what is the difference between the Value added (% of GDP) of Malawi and Value added (% of GDP) of New Zealand?
Ensure brevity in your answer.  29.03. In the year 2004, what is the difference between the Value added (% of GDP) in World and Value added (% of GDP) in Burkina Faso?
Make the answer very short. -30.88. In the year 2004, what is the difference between the Value added (% of GDP) of World and Value added (% of GDP) of Malawi?
Offer a terse response. -31.29. In the year 2004, what is the difference between the Value added (% of GDP) in World and Value added (% of GDP) in New Zealand?
Offer a very short reply. -2.13. In the year 2004, what is the difference between the Value added (% of GDP) in Burkina Faso and Value added (% of GDP) in Malawi?
Make the answer very short. -0.41. In the year 2004, what is the difference between the Value added (% of GDP) in Burkina Faso and Value added (% of GDP) in New Zealand?
Keep it short and to the point. 28.75. In the year 2004, what is the difference between the Value added (% of GDP) of Malawi and Value added (% of GDP) of New Zealand?
Make the answer very short. 29.16. In the year 2005, what is the difference between the Value added (% of GDP) of World and Value added (% of GDP) of Burkina Faso?
Your answer should be compact. -35.71. In the year 2005, what is the difference between the Value added (% of GDP) of World and Value added (% of GDP) of Malawi?
Make the answer very short. -29.79. In the year 2005, what is the difference between the Value added (% of GDP) in World and Value added (% of GDP) in New Zealand?
Keep it short and to the point. -1.53. In the year 2005, what is the difference between the Value added (% of GDP) in Burkina Faso and Value added (% of GDP) in Malawi?
Your answer should be compact. 5.92. In the year 2005, what is the difference between the Value added (% of GDP) of Burkina Faso and Value added (% of GDP) of New Zealand?
Make the answer very short. 34.17. In the year 2005, what is the difference between the Value added (% of GDP) of Malawi and Value added (% of GDP) of New Zealand?
Your response must be concise. 28.26. In the year 2006, what is the difference between the Value added (% of GDP) of World and Value added (% of GDP) of Burkina Faso?
Your response must be concise. -33.59. In the year 2006, what is the difference between the Value added (% of GDP) in World and Value added (% of GDP) in Malawi?
Provide a succinct answer. -28.44. In the year 2006, what is the difference between the Value added (% of GDP) in World and Value added (% of GDP) in New Zealand?
Offer a terse response. -2.27. In the year 2006, what is the difference between the Value added (% of GDP) in Burkina Faso and Value added (% of GDP) in Malawi?
Your answer should be compact. 5.15. In the year 2006, what is the difference between the Value added (% of GDP) of Burkina Faso and Value added (% of GDP) of New Zealand?
Offer a terse response. 31.32. In the year 2006, what is the difference between the Value added (% of GDP) of Malawi and Value added (% of GDP) of New Zealand?
Offer a terse response. 26.17. In the year 2007, what is the difference between the Value added (% of GDP) of World and Value added (% of GDP) of Burkina Faso?
Your response must be concise. -29.6. In the year 2007, what is the difference between the Value added (% of GDP) of World and Value added (% of GDP) of Malawi?
Keep it short and to the point. -28.54. In the year 2007, what is the difference between the Value added (% of GDP) in World and Value added (% of GDP) in New Zealand?
Provide a short and direct response. -3.52. In the year 2007, what is the difference between the Value added (% of GDP) in Burkina Faso and Value added (% of GDP) in Malawi?
Offer a terse response. 1.07. In the year 2007, what is the difference between the Value added (% of GDP) in Burkina Faso and Value added (% of GDP) in New Zealand?
Offer a very short reply. 26.08. In the year 2007, what is the difference between the Value added (% of GDP) of Malawi and Value added (% of GDP) of New Zealand?
Offer a terse response. 25.01. In the year 2008, what is the difference between the Value added (% of GDP) in World and Value added (% of GDP) in Burkina Faso?
Your answer should be very brief. -37.14. In the year 2008, what is the difference between the Value added (% of GDP) of World and Value added (% of GDP) of Malawi?
Make the answer very short. -26.65. In the year 2008, what is the difference between the Value added (% of GDP) in World and Value added (% of GDP) in New Zealand?
Make the answer very short. -2.35. In the year 2008, what is the difference between the Value added (% of GDP) of Burkina Faso and Value added (% of GDP) of Malawi?
Your answer should be compact. 10.49. In the year 2008, what is the difference between the Value added (% of GDP) in Burkina Faso and Value added (% of GDP) in New Zealand?
Offer a very short reply. 34.79. In the year 2008, what is the difference between the Value added (% of GDP) in Malawi and Value added (% of GDP) in New Zealand?
Offer a terse response. 24.3. In the year 2009, what is the difference between the Value added (% of GDP) of World and Value added (% of GDP) of Burkina Faso?
Ensure brevity in your answer.  -32.57. In the year 2009, what is the difference between the Value added (% of GDP) of World and Value added (% of GDP) of Malawi?
Provide a short and direct response. -28.2. In the year 2009, what is the difference between the Value added (% of GDP) in World and Value added (% of GDP) in New Zealand?
Ensure brevity in your answer.  -3.2. In the year 2009, what is the difference between the Value added (% of GDP) in Burkina Faso and Value added (% of GDP) in Malawi?
Provide a short and direct response. 4.38. In the year 2009, what is the difference between the Value added (% of GDP) of Burkina Faso and Value added (% of GDP) of New Zealand?
Give a very brief answer. 29.37. In the year 2009, what is the difference between the Value added (% of GDP) in Malawi and Value added (% of GDP) in New Zealand?
Give a very brief answer. 25. In the year 2010, what is the difference between the Value added (% of GDP) in World and Value added (% of GDP) in Burkina Faso?
Your response must be concise. -32.61. In the year 2010, what is the difference between the Value added (% of GDP) of World and Value added (% of GDP) of Malawi?
Ensure brevity in your answer.  -26.6. In the year 2010, what is the difference between the Value added (% of GDP) of World and Value added (% of GDP) of New Zealand?
Provide a succinct answer. -4.18. In the year 2010, what is the difference between the Value added (% of GDP) of Burkina Faso and Value added (% of GDP) of Malawi?
Your answer should be very brief. 6. In the year 2010, what is the difference between the Value added (% of GDP) of Burkina Faso and Value added (% of GDP) of New Zealand?
Give a very brief answer. 28.43. In the year 2010, what is the difference between the Value added (% of GDP) of Malawi and Value added (% of GDP) of New Zealand?
Your response must be concise. 22.42. What is the ratio of the Value added (% of GDP) in World in 2003 to that in 2004?
Offer a terse response. 1.02. What is the ratio of the Value added (% of GDP) of Burkina Faso in 2003 to that in 2004?
Make the answer very short. 1.07. What is the ratio of the Value added (% of GDP) in Malawi in 2003 to that in 2004?
Offer a terse response. 1.01. What is the ratio of the Value added (% of GDP) in New Zealand in 2003 to that in 2004?
Ensure brevity in your answer.  1.07. What is the ratio of the Value added (% of GDP) of World in 2003 to that in 2005?
Make the answer very short. 1.11. What is the ratio of the Value added (% of GDP) of Burkina Faso in 2003 to that in 2005?
Give a very brief answer. 0.95. What is the ratio of the Value added (% of GDP) in Malawi in 2003 to that in 2005?
Keep it short and to the point. 1.06. What is the ratio of the Value added (% of GDP) of New Zealand in 2003 to that in 2005?
Your answer should be very brief. 1.27. What is the ratio of the Value added (% of GDP) in World in 2003 to that in 2006?
Your response must be concise. 1.18. What is the ratio of the Value added (% of GDP) of Burkina Faso in 2003 to that in 2006?
Your answer should be very brief. 1.01. What is the ratio of the Value added (% of GDP) of Malawi in 2003 to that in 2006?
Your answer should be compact. 1.11. What is the ratio of the Value added (% of GDP) of New Zealand in 2003 to that in 2006?
Provide a short and direct response. 1.14. What is the ratio of the Value added (% of GDP) in World in 2003 to that in 2007?
Your answer should be compact. 1.21. What is the ratio of the Value added (% of GDP) of Burkina Faso in 2003 to that in 2007?
Your answer should be compact. 1.14. What is the ratio of the Value added (% of GDP) in Malawi in 2003 to that in 2007?
Your answer should be very brief. 1.11. What is the ratio of the Value added (% of GDP) in New Zealand in 2003 to that in 2007?
Offer a very short reply. 0.94. What is the ratio of the Value added (% of GDP) of World in 2003 to that in 2008?
Make the answer very short. 1.21. What is the ratio of the Value added (% of GDP) in Burkina Faso in 2003 to that in 2008?
Your answer should be very brief. 0.92. What is the ratio of the Value added (% of GDP) of Malawi in 2003 to that in 2008?
Your response must be concise. 1.18. What is the ratio of the Value added (% of GDP) of New Zealand in 2003 to that in 2008?
Your response must be concise. 1.14. What is the ratio of the Value added (% of GDP) of World in 2003 to that in 2009?
Offer a terse response. 1.23. What is the ratio of the Value added (% of GDP) in Burkina Faso in 2003 to that in 2009?
Offer a terse response. 1.04. What is the ratio of the Value added (% of GDP) in Malawi in 2003 to that in 2009?
Offer a terse response. 1.13. What is the ratio of the Value added (% of GDP) of World in 2003 to that in 2010?
Your answer should be compact. 1.23. What is the ratio of the Value added (% of GDP) in Burkina Faso in 2003 to that in 2010?
Your answer should be compact. 1.04. What is the ratio of the Value added (% of GDP) in Malawi in 2003 to that in 2010?
Keep it short and to the point. 1.19. What is the ratio of the Value added (% of GDP) of New Zealand in 2003 to that in 2010?
Your response must be concise. 0.86. What is the ratio of the Value added (% of GDP) in World in 2004 to that in 2005?
Make the answer very short. 1.1. What is the ratio of the Value added (% of GDP) in Burkina Faso in 2004 to that in 2005?
Offer a very short reply. 0.88. What is the ratio of the Value added (% of GDP) in Malawi in 2004 to that in 2005?
Your response must be concise. 1.05. What is the ratio of the Value added (% of GDP) of New Zealand in 2004 to that in 2005?
Ensure brevity in your answer.  1.19. What is the ratio of the Value added (% of GDP) in World in 2004 to that in 2006?
Make the answer very short. 1.16. What is the ratio of the Value added (% of GDP) of Malawi in 2004 to that in 2006?
Keep it short and to the point. 1.11. What is the ratio of the Value added (% of GDP) in New Zealand in 2004 to that in 2006?
Make the answer very short. 1.07. What is the ratio of the Value added (% of GDP) of World in 2004 to that in 2007?
Make the answer very short. 1.19. What is the ratio of the Value added (% of GDP) of Burkina Faso in 2004 to that in 2007?
Make the answer very short. 1.06. What is the ratio of the Value added (% of GDP) in Malawi in 2004 to that in 2007?
Ensure brevity in your answer.  1.11. What is the ratio of the Value added (% of GDP) of New Zealand in 2004 to that in 2007?
Your answer should be very brief. 0.88. What is the ratio of the Value added (% of GDP) of World in 2004 to that in 2008?
Provide a short and direct response. 1.19. What is the ratio of the Value added (% of GDP) of Burkina Faso in 2004 to that in 2008?
Give a very brief answer. 0.86. What is the ratio of the Value added (% of GDP) in Malawi in 2004 to that in 2008?
Ensure brevity in your answer.  1.18. What is the ratio of the Value added (% of GDP) in New Zealand in 2004 to that in 2008?
Offer a very short reply. 1.07. What is the ratio of the Value added (% of GDP) in World in 2004 to that in 2009?
Your response must be concise. 1.21. What is the ratio of the Value added (% of GDP) in Burkina Faso in 2004 to that in 2009?
Provide a short and direct response. 0.97. What is the ratio of the Value added (% of GDP) of Malawi in 2004 to that in 2009?
Give a very brief answer. 1.12. What is the ratio of the Value added (% of GDP) in New Zealand in 2004 to that in 2009?
Provide a succinct answer. 0.93. What is the ratio of the Value added (% of GDP) in World in 2004 to that in 2010?
Make the answer very short. 1.21. What is the ratio of the Value added (% of GDP) in Burkina Faso in 2004 to that in 2010?
Keep it short and to the point. 0.97. What is the ratio of the Value added (% of GDP) in Malawi in 2004 to that in 2010?
Keep it short and to the point. 1.18. What is the ratio of the Value added (% of GDP) in New Zealand in 2004 to that in 2010?
Offer a very short reply. 0.8. What is the ratio of the Value added (% of GDP) in World in 2005 to that in 2006?
Give a very brief answer. 1.06. What is the ratio of the Value added (% of GDP) of Burkina Faso in 2005 to that in 2006?
Make the answer very short. 1.06. What is the ratio of the Value added (% of GDP) in Malawi in 2005 to that in 2006?
Give a very brief answer. 1.05. What is the ratio of the Value added (% of GDP) of New Zealand in 2005 to that in 2006?
Your response must be concise. 0.9. What is the ratio of the Value added (% of GDP) of World in 2005 to that in 2007?
Make the answer very short. 1.08. What is the ratio of the Value added (% of GDP) in Burkina Faso in 2005 to that in 2007?
Provide a succinct answer. 1.19. What is the ratio of the Value added (% of GDP) in Malawi in 2005 to that in 2007?
Your answer should be compact. 1.05. What is the ratio of the Value added (% of GDP) in New Zealand in 2005 to that in 2007?
Your answer should be very brief. 0.74. What is the ratio of the Value added (% of GDP) of World in 2005 to that in 2008?
Offer a very short reply. 1.09. What is the ratio of the Value added (% of GDP) of Burkina Faso in 2005 to that in 2008?
Your response must be concise. 0.97. What is the ratio of the Value added (% of GDP) of Malawi in 2005 to that in 2008?
Provide a short and direct response. 1.11. What is the ratio of the Value added (% of GDP) of New Zealand in 2005 to that in 2008?
Your response must be concise. 0.9. What is the ratio of the Value added (% of GDP) of World in 2005 to that in 2009?
Offer a very short reply. 1.11. What is the ratio of the Value added (% of GDP) of Burkina Faso in 2005 to that in 2009?
Provide a short and direct response. 1.1. What is the ratio of the Value added (% of GDP) in Malawi in 2005 to that in 2009?
Offer a very short reply. 1.06. What is the ratio of the Value added (% of GDP) in New Zealand in 2005 to that in 2009?
Provide a succinct answer. 0.78. What is the ratio of the Value added (% of GDP) in World in 2005 to that in 2010?
Give a very brief answer. 1.1. What is the ratio of the Value added (% of GDP) in Burkina Faso in 2005 to that in 2010?
Offer a terse response. 1.1. What is the ratio of the Value added (% of GDP) in Malawi in 2005 to that in 2010?
Make the answer very short. 1.12. What is the ratio of the Value added (% of GDP) in New Zealand in 2005 to that in 2010?
Your response must be concise. 0.68. What is the ratio of the Value added (% of GDP) of World in 2006 to that in 2007?
Offer a terse response. 1.02. What is the ratio of the Value added (% of GDP) of Burkina Faso in 2006 to that in 2007?
Give a very brief answer. 1.12. What is the ratio of the Value added (% of GDP) of New Zealand in 2006 to that in 2007?
Your answer should be compact. 0.82. What is the ratio of the Value added (% of GDP) of World in 2006 to that in 2008?
Your answer should be compact. 1.02. What is the ratio of the Value added (% of GDP) in Burkina Faso in 2006 to that in 2008?
Your answer should be very brief. 0.91. What is the ratio of the Value added (% of GDP) in Malawi in 2006 to that in 2008?
Provide a succinct answer. 1.06. What is the ratio of the Value added (% of GDP) of New Zealand in 2006 to that in 2008?
Your response must be concise. 1. What is the ratio of the Value added (% of GDP) of World in 2006 to that in 2009?
Your response must be concise. 1.05. What is the ratio of the Value added (% of GDP) in Burkina Faso in 2006 to that in 2009?
Ensure brevity in your answer.  1.03. What is the ratio of the Value added (% of GDP) of Malawi in 2006 to that in 2009?
Give a very brief answer. 1.01. What is the ratio of the Value added (% of GDP) in New Zealand in 2006 to that in 2009?
Your answer should be compact. 0.87. What is the ratio of the Value added (% of GDP) of World in 2006 to that in 2010?
Keep it short and to the point. 1.04. What is the ratio of the Value added (% of GDP) in Burkina Faso in 2006 to that in 2010?
Your answer should be compact. 1.03. What is the ratio of the Value added (% of GDP) of Malawi in 2006 to that in 2010?
Your answer should be very brief. 1.07. What is the ratio of the Value added (% of GDP) of New Zealand in 2006 to that in 2010?
Ensure brevity in your answer.  0.75. What is the ratio of the Value added (% of GDP) of Burkina Faso in 2007 to that in 2008?
Offer a terse response. 0.81. What is the ratio of the Value added (% of GDP) in Malawi in 2007 to that in 2008?
Offer a terse response. 1.06. What is the ratio of the Value added (% of GDP) of New Zealand in 2007 to that in 2008?
Provide a short and direct response. 1.22. What is the ratio of the Value added (% of GDP) of World in 2007 to that in 2009?
Your response must be concise. 1.02. What is the ratio of the Value added (% of GDP) in Burkina Faso in 2007 to that in 2009?
Make the answer very short. 0.92. What is the ratio of the Value added (% of GDP) of Malawi in 2007 to that in 2009?
Provide a succinct answer. 1.01. What is the ratio of the Value added (% of GDP) of New Zealand in 2007 to that in 2009?
Your answer should be compact. 1.06. What is the ratio of the Value added (% of GDP) of World in 2007 to that in 2010?
Ensure brevity in your answer.  1.02. What is the ratio of the Value added (% of GDP) of Burkina Faso in 2007 to that in 2010?
Provide a succinct answer. 0.92. What is the ratio of the Value added (% of GDP) in Malawi in 2007 to that in 2010?
Offer a very short reply. 1.07. What is the ratio of the Value added (% of GDP) in New Zealand in 2007 to that in 2010?
Make the answer very short. 0.92. What is the ratio of the Value added (% of GDP) in World in 2008 to that in 2009?
Your answer should be compact. 1.02. What is the ratio of the Value added (% of GDP) in Burkina Faso in 2008 to that in 2009?
Keep it short and to the point. 1.13. What is the ratio of the Value added (% of GDP) of New Zealand in 2008 to that in 2009?
Your answer should be compact. 0.87. What is the ratio of the Value added (% of GDP) in World in 2008 to that in 2010?
Offer a very short reply. 1.02. What is the ratio of the Value added (% of GDP) in Burkina Faso in 2008 to that in 2010?
Provide a short and direct response. 1.13. What is the ratio of the Value added (% of GDP) of Malawi in 2008 to that in 2010?
Provide a short and direct response. 1. What is the ratio of the Value added (% of GDP) of New Zealand in 2008 to that in 2010?
Provide a succinct answer. 0.75. What is the ratio of the Value added (% of GDP) of Malawi in 2009 to that in 2010?
Provide a succinct answer. 1.05. What is the ratio of the Value added (% of GDP) of New Zealand in 2009 to that in 2010?
Your answer should be compact. 0.86. What is the difference between the highest and the second highest Value added (% of GDP) of World?
Keep it short and to the point. 0.06. What is the difference between the highest and the second highest Value added (% of GDP) in Burkina Faso?
Offer a very short reply. 1.17. What is the difference between the highest and the second highest Value added (% of GDP) of Malawi?
Offer a terse response. 0.26. What is the difference between the highest and the second highest Value added (% of GDP) in New Zealand?
Your response must be concise. 0.6. What is the difference between the highest and the lowest Value added (% of GDP) of World?
Provide a short and direct response. 0.7. What is the difference between the highest and the lowest Value added (% of GDP) of Burkina Faso?
Offer a terse response. 7.54. What is the difference between the highest and the lowest Value added (% of GDP) in Malawi?
Give a very brief answer. 5.58. What is the difference between the highest and the lowest Value added (% of GDP) in New Zealand?
Your answer should be compact. 2.33. 